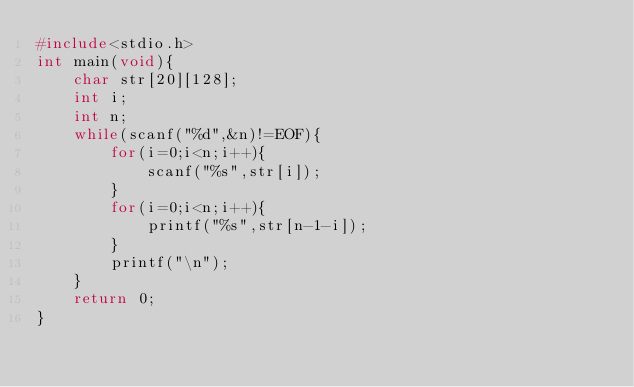<code> <loc_0><loc_0><loc_500><loc_500><_C_>#include<stdio.h>
int main(void){
	char str[20][128];
	int i;
	int n;
	while(scanf("%d",&n)!=EOF){
		for(i=0;i<n;i++){
			scanf("%s",str[i]);
		}
		for(i=0;i<n;i++){
			printf("%s",str[n-1-i]);
		}
		printf("\n");
	}
	return 0;
}</code> 